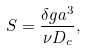Convert formula to latex. <formula><loc_0><loc_0><loc_500><loc_500>S = \frac { \delta g a ^ { 3 } } { \nu D _ { c } } ,</formula> 